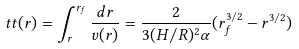<formula> <loc_0><loc_0><loc_500><loc_500>t t ( r ) = \int ^ { r _ { f } } _ { r } \frac { d r } { v ( r ) } = \frac { 2 } { 3 ( H / R ) ^ { 2 } \alpha } ( r _ { f } ^ { 3 / 2 } - r ^ { 3 / 2 } )</formula> 